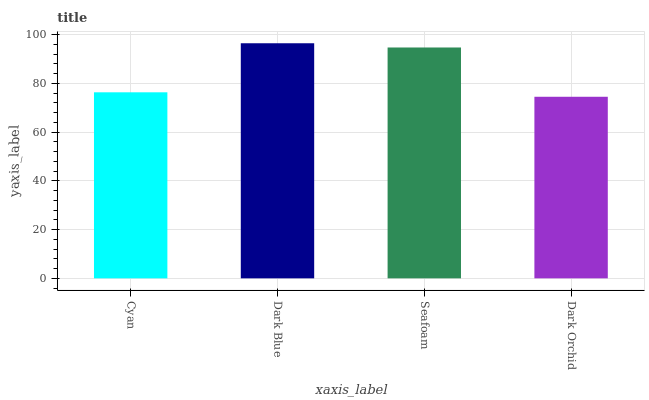Is Dark Orchid the minimum?
Answer yes or no. Yes. Is Dark Blue the maximum?
Answer yes or no. Yes. Is Seafoam the minimum?
Answer yes or no. No. Is Seafoam the maximum?
Answer yes or no. No. Is Dark Blue greater than Seafoam?
Answer yes or no. Yes. Is Seafoam less than Dark Blue?
Answer yes or no. Yes. Is Seafoam greater than Dark Blue?
Answer yes or no. No. Is Dark Blue less than Seafoam?
Answer yes or no. No. Is Seafoam the high median?
Answer yes or no. Yes. Is Cyan the low median?
Answer yes or no. Yes. Is Dark Blue the high median?
Answer yes or no. No. Is Seafoam the low median?
Answer yes or no. No. 